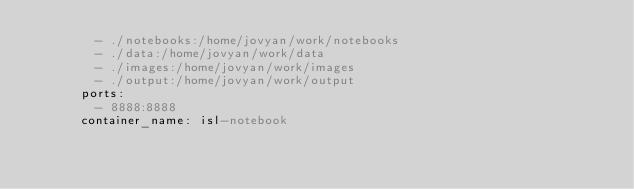<code> <loc_0><loc_0><loc_500><loc_500><_YAML_>        - ./notebooks:/home/jovyan/work/notebooks
        - ./data:/home/jovyan/work/data
        - ./images:/home/jovyan/work/images
        - ./output:/home/jovyan/work/output
      ports:
        - 8888:8888
      container_name: isl-notebook</code> 